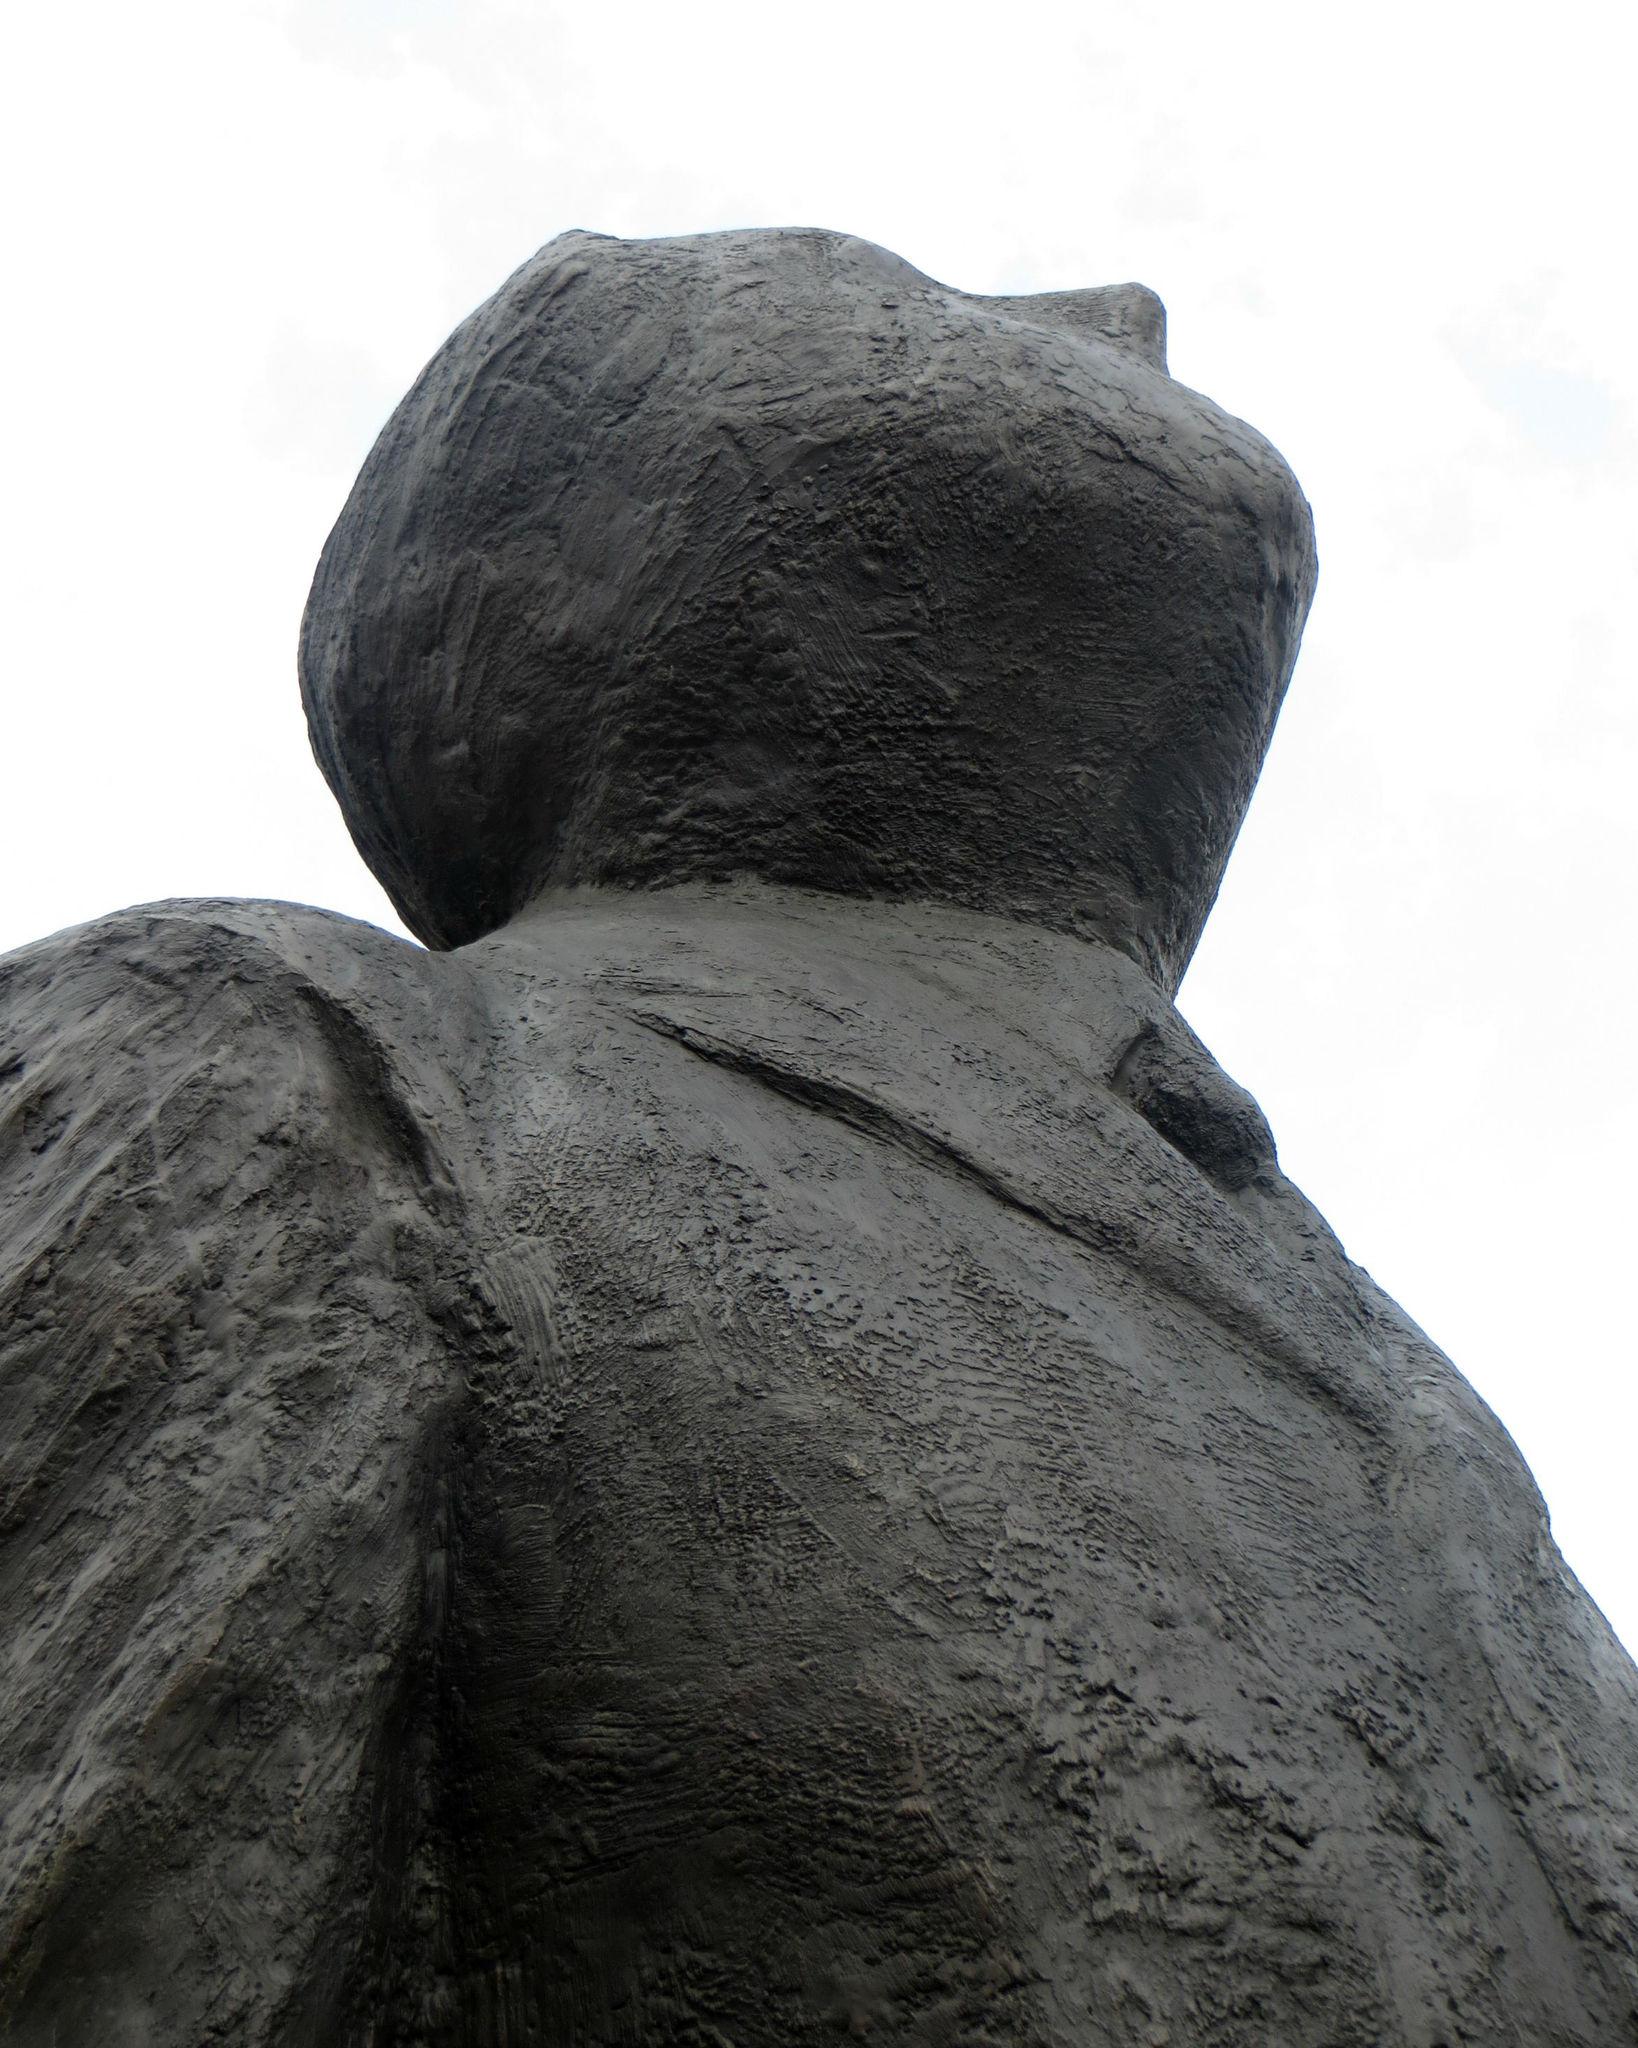What is the main subject of the picture? The main subject of the picture is a statue of a man. What can be seen at the top of the image? The sky is visible at the top of the image. What is present in the sky? Clouds are present in the sky. How many cows can be seen grazing in the background of the image? There are no cows present in the image; it features a statue of a man and clouds in the sky. What type of toothbrush is the statue holding in the image? The statue is not holding a toothbrush in the image; it is a statue of a man without any objects in its hands. 